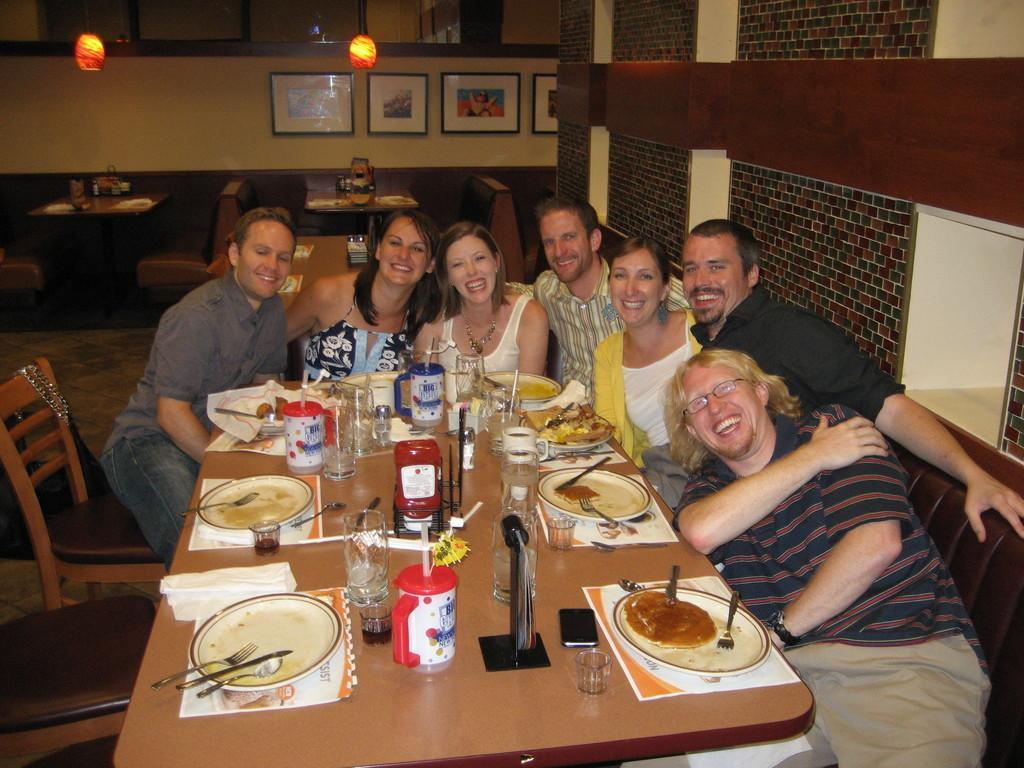How would you summarize this image in a sentence or two? This picture describes about group of people who are all seated on the chair, in front of them we can see plate, jug, glass and some other objects on the table in the background we can see wall frames and lights. 